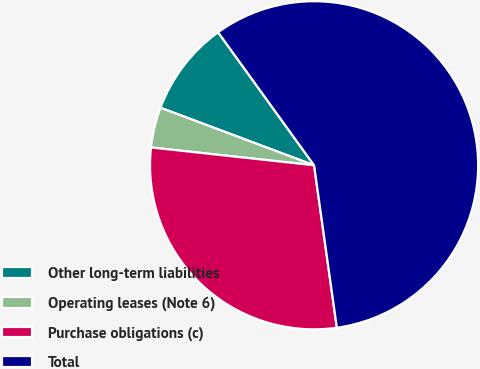Convert chart. <chart><loc_0><loc_0><loc_500><loc_500><pie_chart><fcel>Other long-term liabilities<fcel>Operating leases (Note 6)<fcel>Purchase obligations (c)<fcel>Total<nl><fcel>9.35%<fcel>3.97%<fcel>28.95%<fcel>57.73%<nl></chart> 